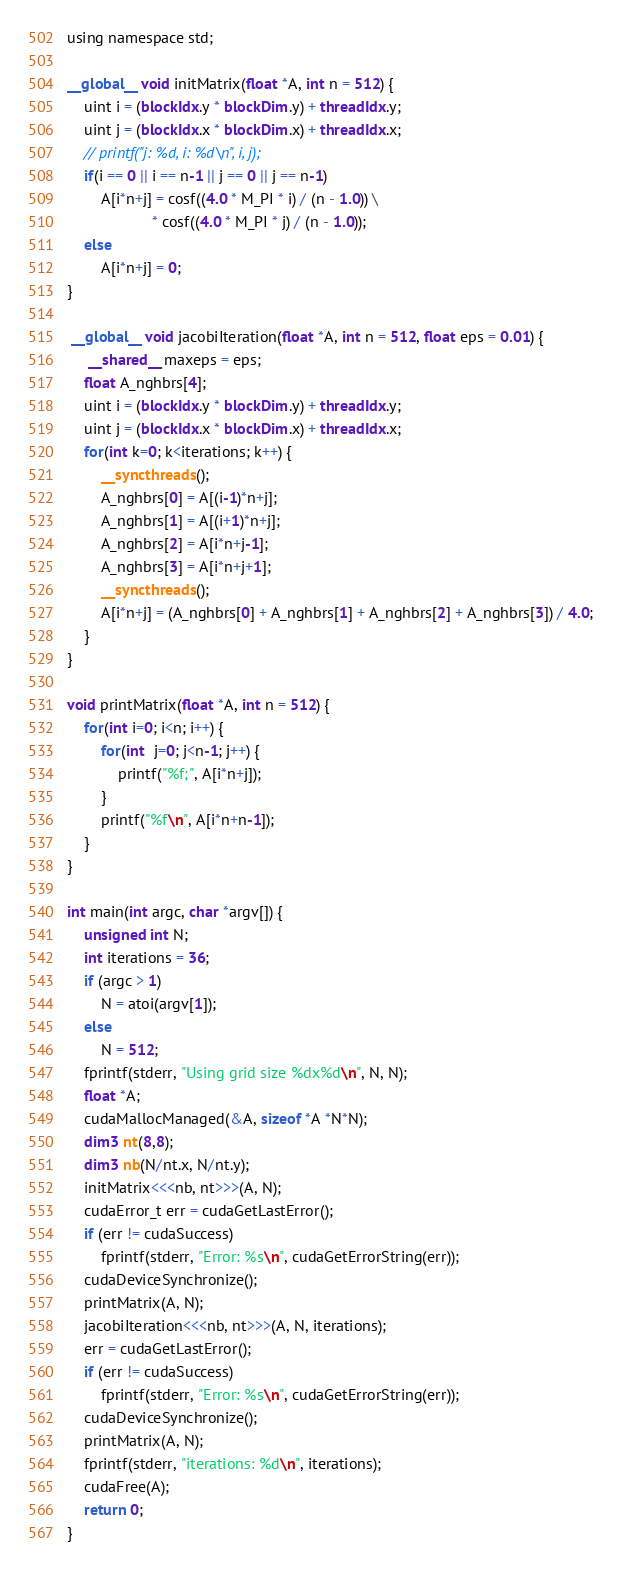Convert code to text. <code><loc_0><loc_0><loc_500><loc_500><_Cuda_>
using namespace std;

__global__ void initMatrix(float *A, int n = 512) {
    uint i = (blockIdx.y * blockDim.y) + threadIdx.y;
    uint j = (blockIdx.x * blockDim.x) + threadIdx.x;
    // printf("j: %d, i: %d\n", i, j);
    if(i == 0 || i == n-1 || j == 0 || j == n-1)
        A[i*n+j] = cosf((4.0 * M_PI * i) / (n - 1.0)) \
                    * cosf((4.0 * M_PI * j) / (n - 1.0));
    else
        A[i*n+j] = 0;
}

 __global__ void jacobiIteration(float *A, int n = 512, float eps = 0.01) {
     __shared__ maxeps = eps;
    float A_nghbrs[4];
    uint i = (blockIdx.y * blockDim.y) + threadIdx.y;
    uint j = (blockIdx.x * blockDim.x) + threadIdx.x;
    for(int k=0; k<iterations; k++) {
        __syncthreads();
        A_nghbrs[0] = A[(i-1)*n+j];
        A_nghbrs[1] = A[(i+1)*n+j];
        A_nghbrs[2] = A[i*n+j-1];
        A_nghbrs[3] = A[i*n+j+1];
        __syncthreads();
        A[i*n+j] = (A_nghbrs[0] + A_nghbrs[1] + A_nghbrs[2] + A_nghbrs[3]) / 4.0;
    }
}

void printMatrix(float *A, int n = 512) {
    for(int i=0; i<n; i++) {
        for(int  j=0; j<n-1; j++) {
            printf("%f;", A[i*n+j]);
        }
        printf("%f\n", A[i*n+n-1]);        
    }
}

int main(int argc, char *argv[]) {
    unsigned int N;
    int iterations = 36;
    if (argc > 1)
        N = atoi(argv[1]);
    else
        N = 512;
    fprintf(stderr, "Using grid size %dx%d\n", N, N);                
    float *A;
    cudaMallocManaged(&A, sizeof *A *N*N);
    dim3 nt(8,8);
    dim3 nb(N/nt.x, N/nt.y);
    initMatrix<<<nb, nt>>>(A, N);
    cudaError_t err = cudaGetLastError();
    if (err != cudaSuccess) 
        fprintf(stderr, "Error: %s\n", cudaGetErrorString(err));
    cudaDeviceSynchronize();        
    printMatrix(A, N);
    jacobiIteration<<<nb, nt>>>(A, N, iterations);
    err = cudaGetLastError();
    if (err != cudaSuccess) 
        fprintf(stderr, "Error: %s\n", cudaGetErrorString(err));
    cudaDeviceSynchronize();            
    printMatrix(A, N);
    fprintf(stderr, "iterations: %d\n", iterations);    
    cudaFree(A);
    return 0;
}</code> 